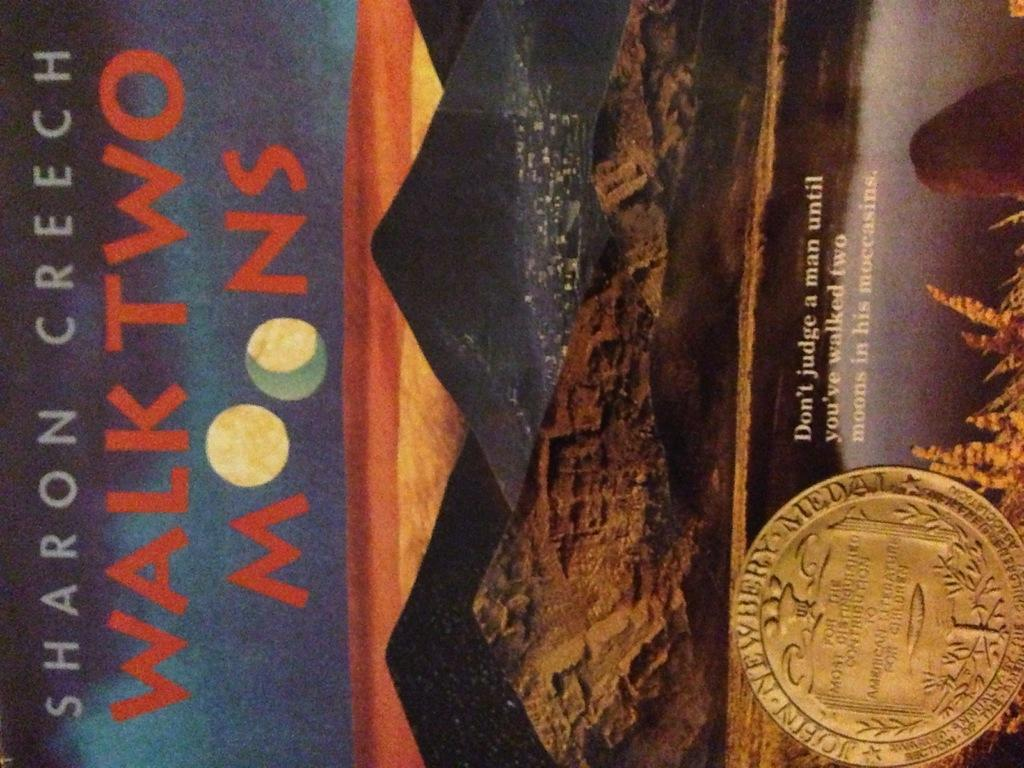<image>
Offer a succinct explanation of the picture presented. a book titled 'walk two moons' by sharon creech 